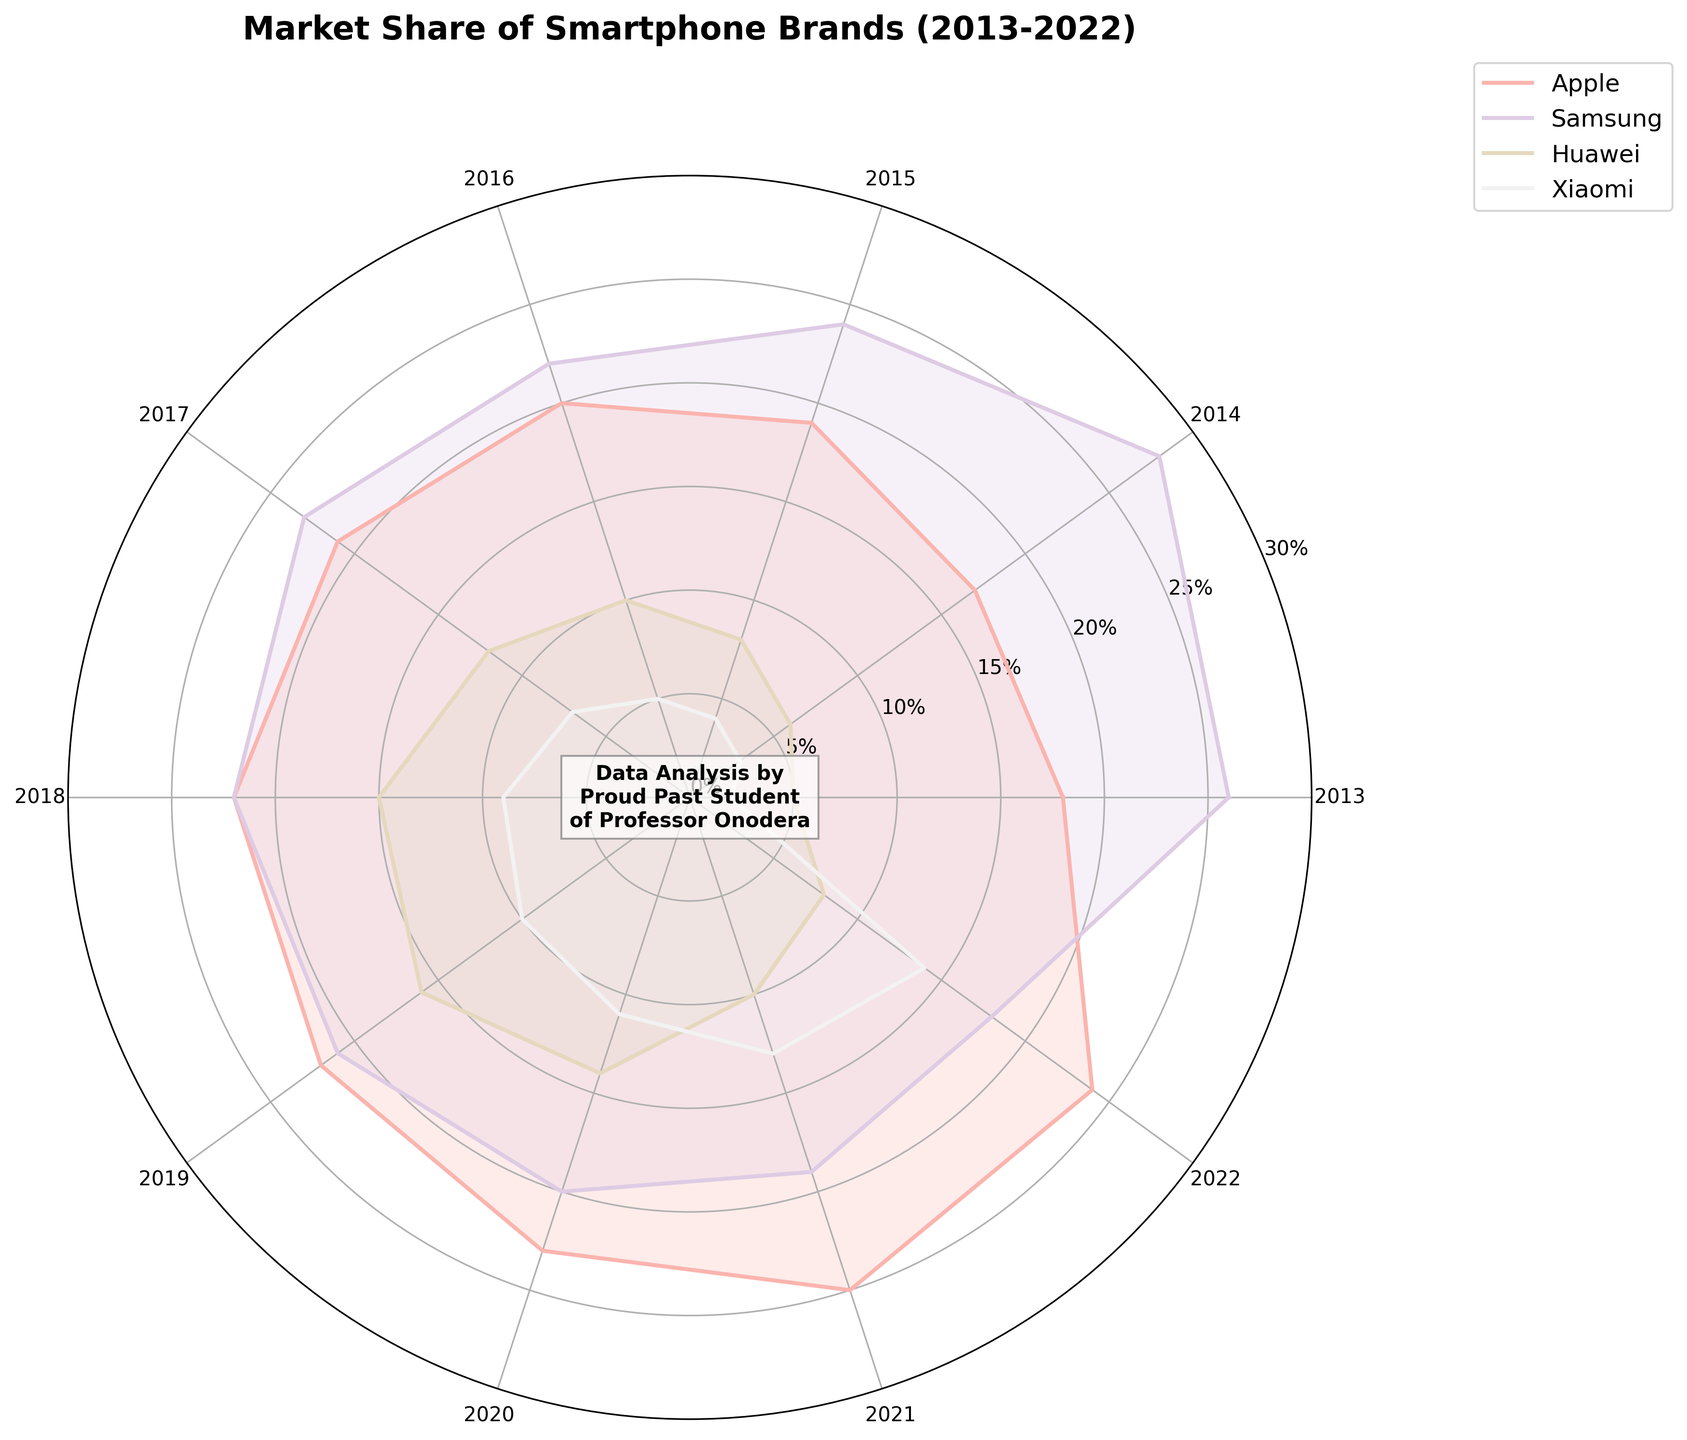How many brands are being compared in the chart? The figure shows data for Apple, Samsung, Huawei, and Xiaomi, so there are four brands being compared.
Answer: 4 Which brand has the highest market share in 2022? The polar area chart shows the data points for each year. For 2022, Apple's market share is about 24%, which is the highest compared to other brands.
Answer: Apple Did Samsung's market share increase or decrease from 2013 to 2022? Samsung's market share starts at 26% in 2013 and goes down to 18% in 2022, indicating a decrease over the decade.
Answer: Decrease Which year did Huawei experience the highest market share, and what was it? Looking at the chart for the largest radial extent at Huawei's segment, the highest market share was in 2019 at 16%.
Answer: 2019, 16% What is the title of the chart? The title of the chart can be seen at the top and it is "Market Share of Smartphone Brands (2013-2022)".
Answer: Market Share of Smartphone Brands (2013-2022) Compare the market share trends of Apple and Xiaomi over the last decade. Apple's market share steadily increased from 18% to 24%, while Xiaomi's market share also increased from 2% to 14%, showing growth for both brands. However, Apple's increase is more consistent and less steep than Xiaomi's.
Answer: Both increased, Apple more consistent than Xiaomi What was the percentage point difference in Apple's market share between 2015 and 2022? Apple's market share in 2015 was 19% and in 2022 it was 24%. The difference is calculated as 24% - 19% = 5%.
Answer: 5% In which year did Xiaomi's market share surpass Huawei's? By looking at the lines' intersections, Xiaomi surpassed Huawei in 2021 with respective market shares of 13% and 10%.
Answer: 2021 Which brand had the least market share in 2013, and what was it? The smallest area in 2013 belongs to Xiaomi with a market share of 2%.
Answer: Xiaomi, 2% During which years did Samsung's market share fall below 20%? The chart shows that Samsung's market share fell below 20% starting from 2021 onwards.
Answer: 2021, 2022 